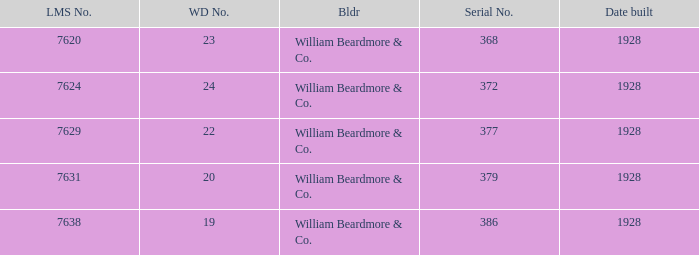Name the builder for wd number being 22 William Beardmore & Co. 